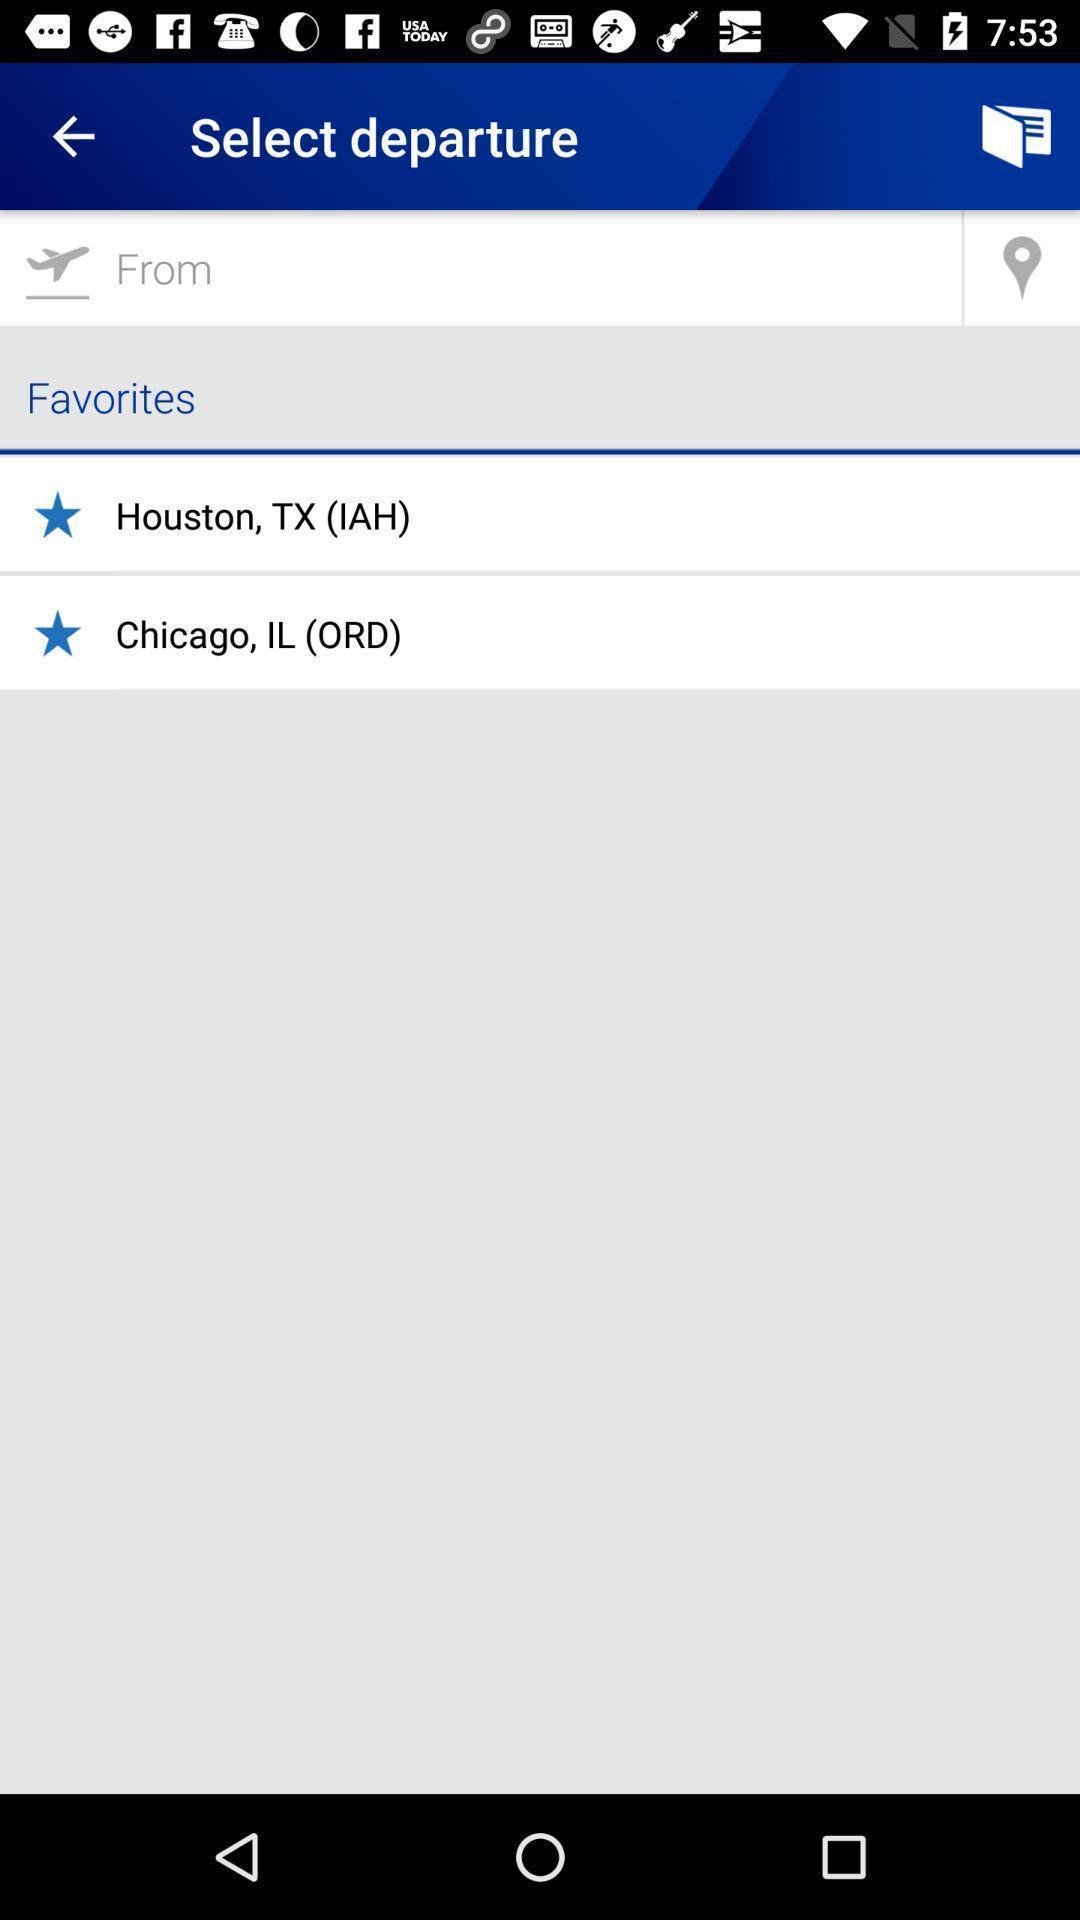Describe the content in this image. Page shows to select flight departures in flight booking app. 